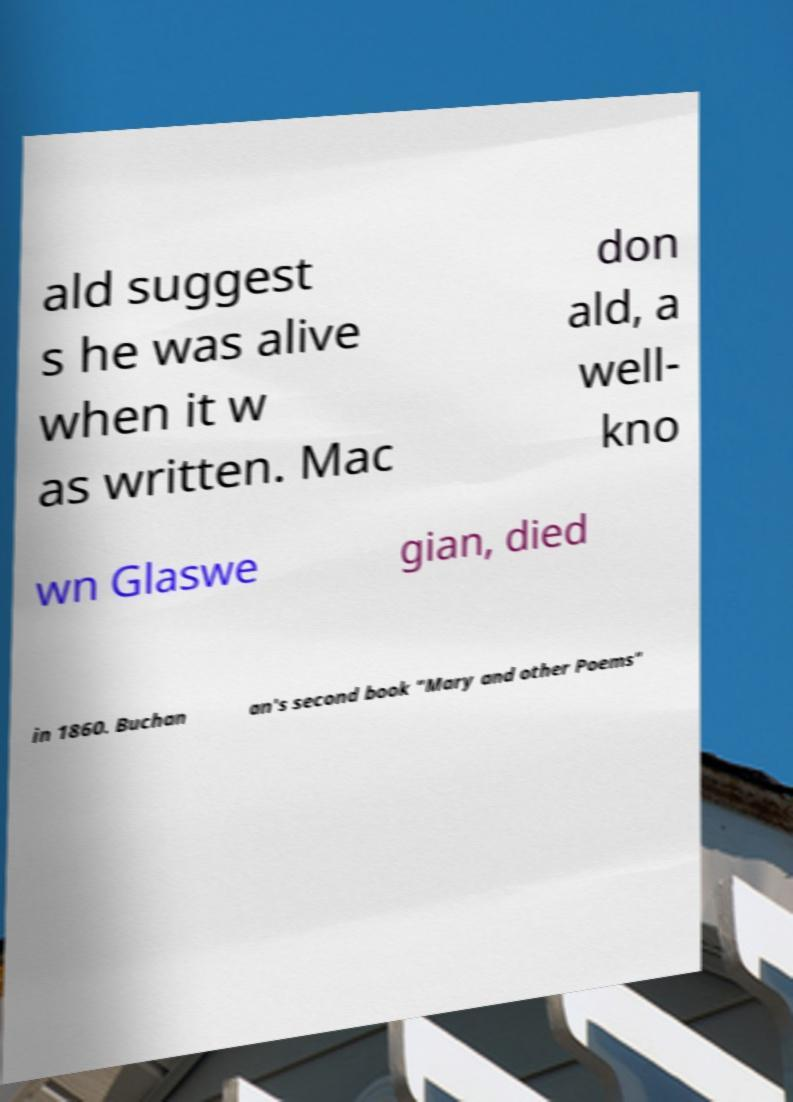Please read and relay the text visible in this image. What does it say? ald suggest s he was alive when it w as written. Mac don ald, a well- kno wn Glaswe gian, died in 1860. Buchan an's second book "Mary and other Poems" 